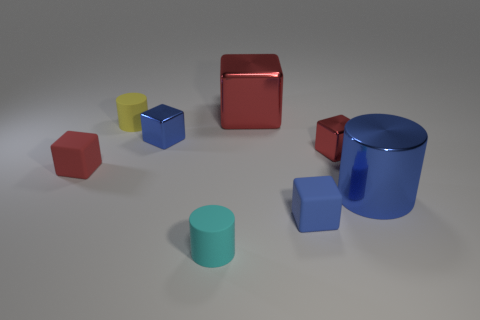Do the red shiny object in front of the big shiny block and the big thing on the left side of the tiny blue matte thing have the same shape?
Your answer should be compact. Yes. What number of blue blocks are to the right of the large red shiny cube?
Give a very brief answer. 1. Is the cylinder that is left of the tiny blue metallic cube made of the same material as the cyan cylinder?
Provide a succinct answer. Yes. What is the color of the large shiny object that is the same shape as the red rubber thing?
Your response must be concise. Red. What shape is the tiny yellow matte thing?
Provide a succinct answer. Cylinder. What number of things are tiny red shiny cubes or small rubber objects?
Keep it short and to the point. 5. There is a matte cube that is behind the big blue thing; is it the same color as the large thing on the left side of the big blue shiny cylinder?
Your response must be concise. Yes. What number of other things are the same shape as the tiny yellow rubber thing?
Give a very brief answer. 2. Is there a tiny blue matte block?
Ensure brevity in your answer.  Yes. How many things are tiny brown things or blue cubes left of the big block?
Offer a very short reply. 1. 